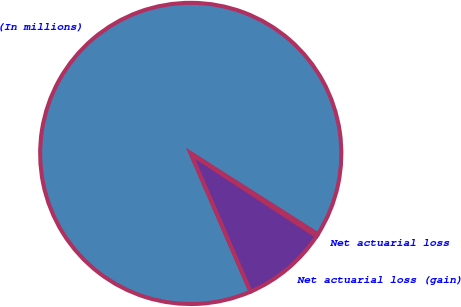Convert chart to OTSL. <chart><loc_0><loc_0><loc_500><loc_500><pie_chart><fcel>(In millions)<fcel>Net actuarial loss (gain)<fcel>Net actuarial loss<nl><fcel>90.52%<fcel>9.25%<fcel>0.22%<nl></chart> 